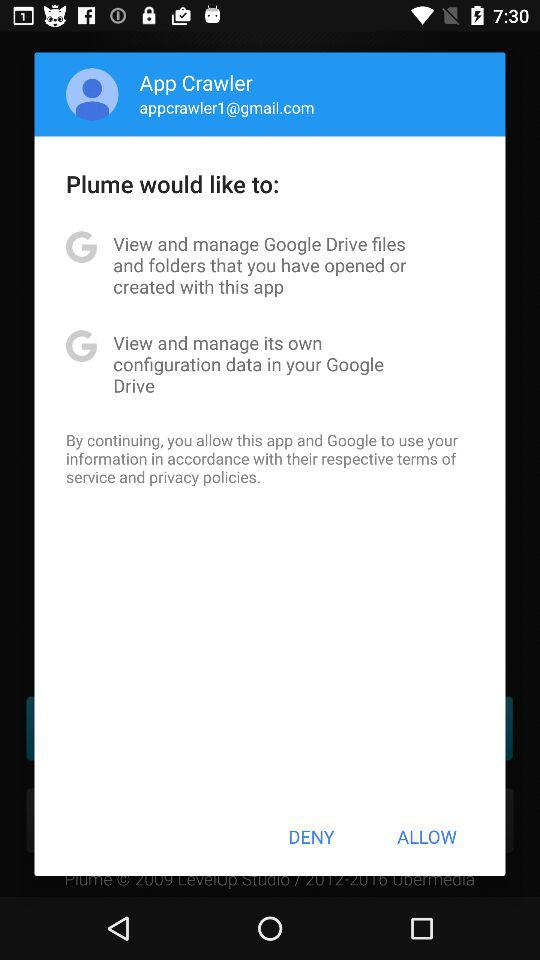What is the given email address? The given email address is appcrawler1@gmail.com. 